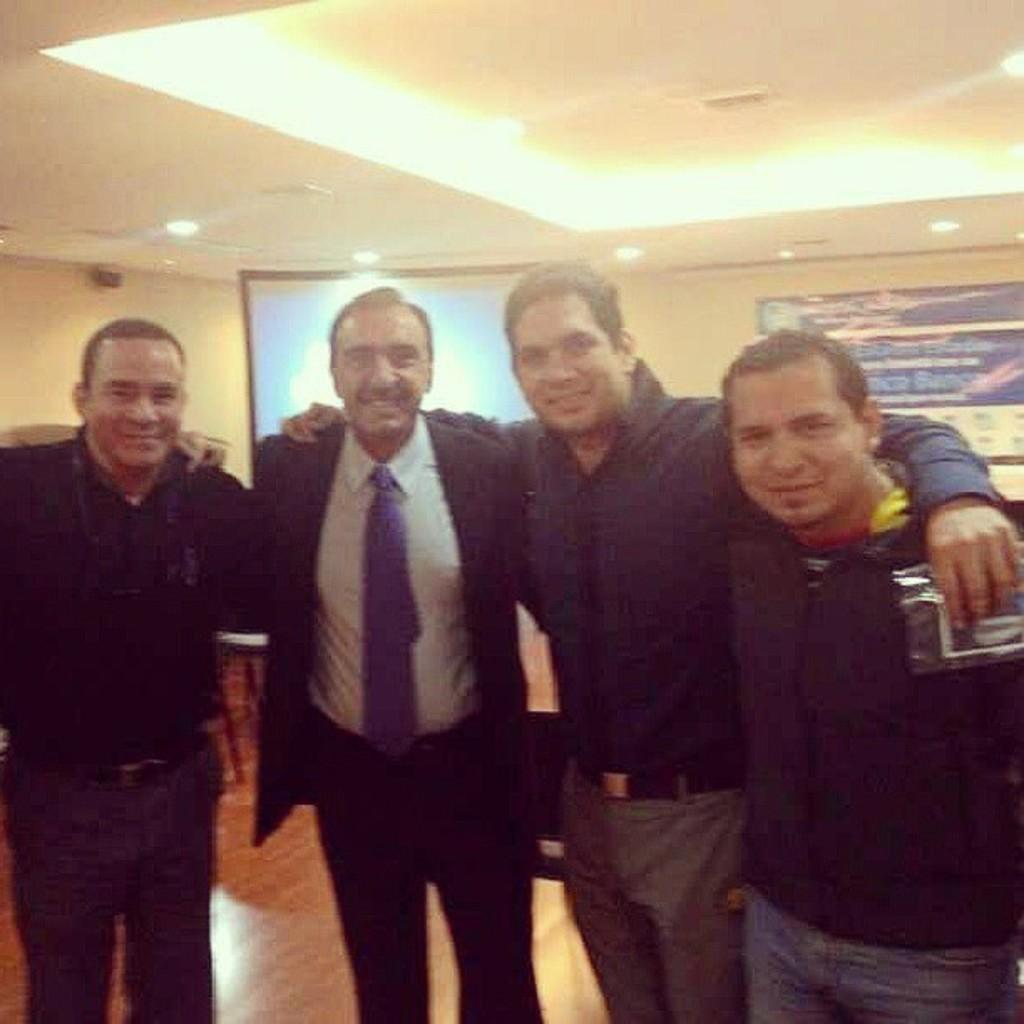How many people are present in the image? There are four people standing in the image. What can be observed about the clothing of the people in the image? The people are wearing different color dresses. What is located in the background of the image? There is a screen and boards on the wall in the background of the image. What can be seen at the top of the image? There are lights visible in the top of the image. What type of scarf is draped over the dust on the floor in the image? There is no scarf or dust present in the image. How many family members are visible in the image? The term "family" is not mentioned in the provided facts, so it cannot be determined how many family members are visible in the image. 